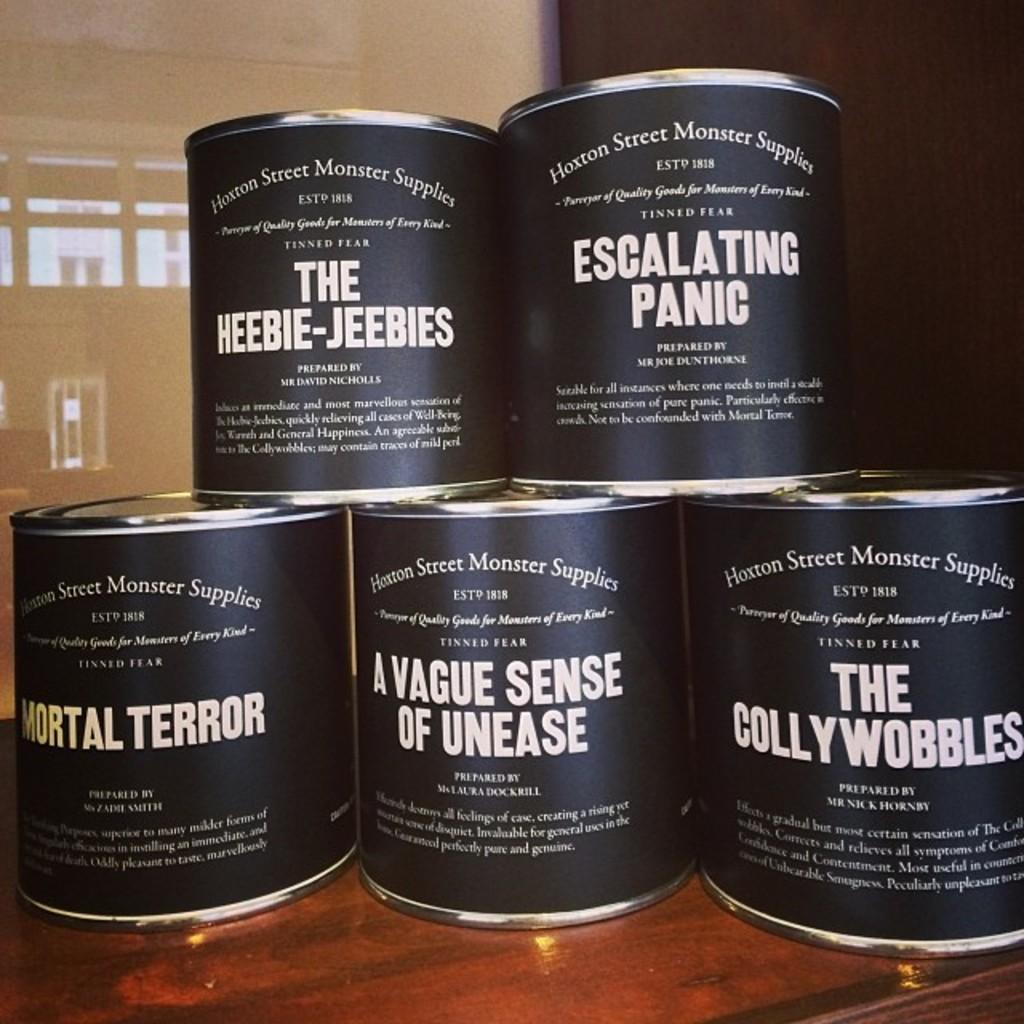<image>
Relay a brief, clear account of the picture shown. Five different cans of Tinned Fear from Haxton Street Monter Supplies are stacked up in a pyramind shape. 